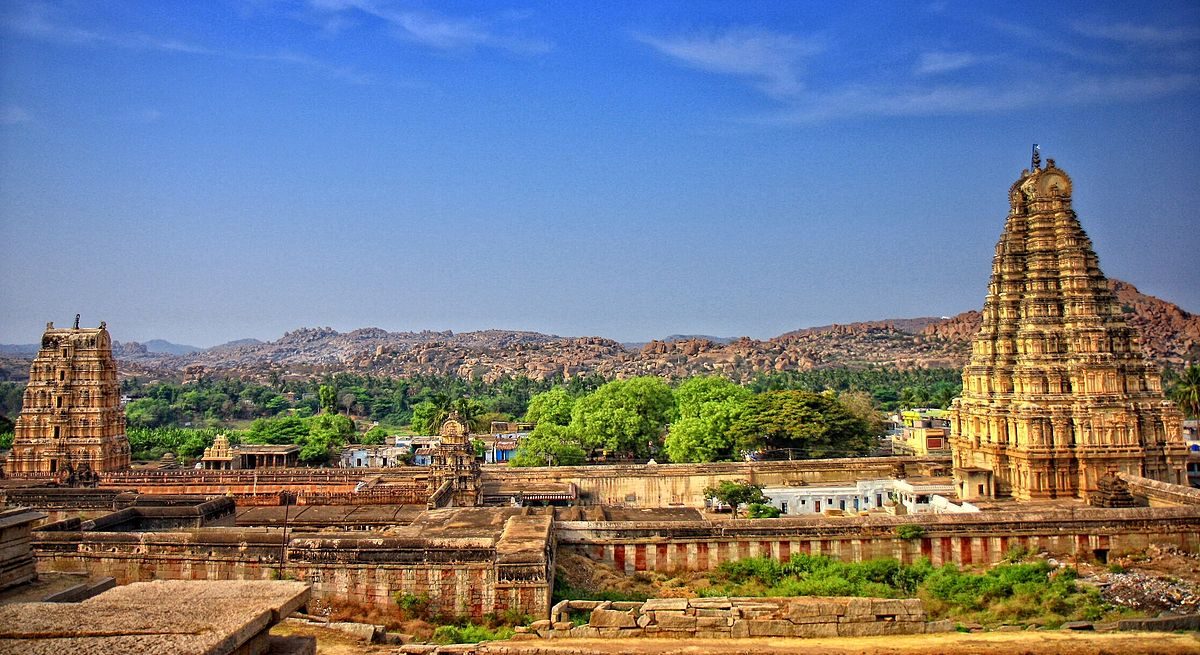What are some architectural details visible in the image that highlight the temple's design? The Virupaksha Temple showcases several hallmark features of Dravidian temple architecture. Visible in the image is the majestic gopuram, or entrance tower, adorned with intricately carved tiers diminishing in size as they ascend towards an apex, not just architectural marvels but also encoded with religious symbolism. Horizontal friezes run along the temple's outer walls, teeming with sculptures and bas-reliefs depicting stories from Hindu texts. The kalasa at the top of the gopuram, a vase-shaped architectural element, signifies bounty and prosperity. You can also spot the pillared halls, or mantapas, used for various temple functions and gatherings, featuring ornate columns each with unique carvings, reflecting the temple's use as a social and cultural hub. 